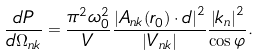<formula> <loc_0><loc_0><loc_500><loc_500>\frac { d P } { d \Omega _ { n k } } = \frac { \pi ^ { 2 } \omega _ { 0 } ^ { 2 } } { V } \frac { \left | A _ { n k } ( r _ { 0 } ) \cdot d \right | ^ { 2 } } { \left | V _ { n k } \right | } \frac { \left | k _ { n } \right | ^ { 2 } } { \cos \varphi } .</formula> 